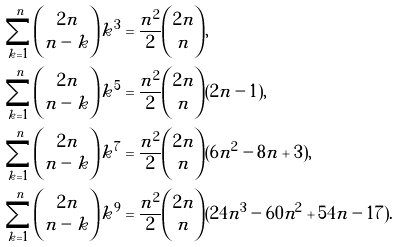<formula> <loc_0><loc_0><loc_500><loc_500>\sum _ { k = 1 } ^ { n } { 2 n \choose n - k } k ^ { 3 } & = \frac { n ^ { 2 } } { 2 } { 2 n \choose n } , \\ \sum _ { k = 1 } ^ { n } { 2 n \choose n - k } k ^ { 5 } & = \frac { n ^ { 2 } } { 2 } { 2 n \choose n } ( 2 n - 1 ) , \\ \sum _ { k = 1 } ^ { n } { 2 n \choose n - k } k ^ { 7 } & = \frac { n ^ { 2 } } { 2 } { 2 n \choose n } ( 6 n ^ { 2 } - 8 n + 3 ) , \\ \sum _ { k = 1 } ^ { n } { 2 n \choose n - k } k ^ { 9 } & = \frac { n ^ { 2 } } { 2 } { 2 n \choose n } ( 2 4 n ^ { 3 } - 6 0 n ^ { 2 } + 5 4 n - 1 7 ) .</formula> 